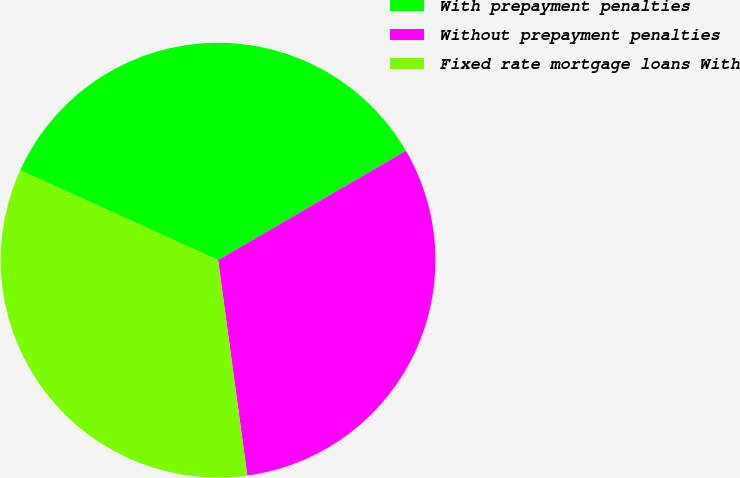Convert chart to OTSL. <chart><loc_0><loc_0><loc_500><loc_500><pie_chart><fcel>With prepayment penalties<fcel>Without prepayment penalties<fcel>Fixed rate mortgage loans With<nl><fcel>34.82%<fcel>31.25%<fcel>33.93%<nl></chart> 